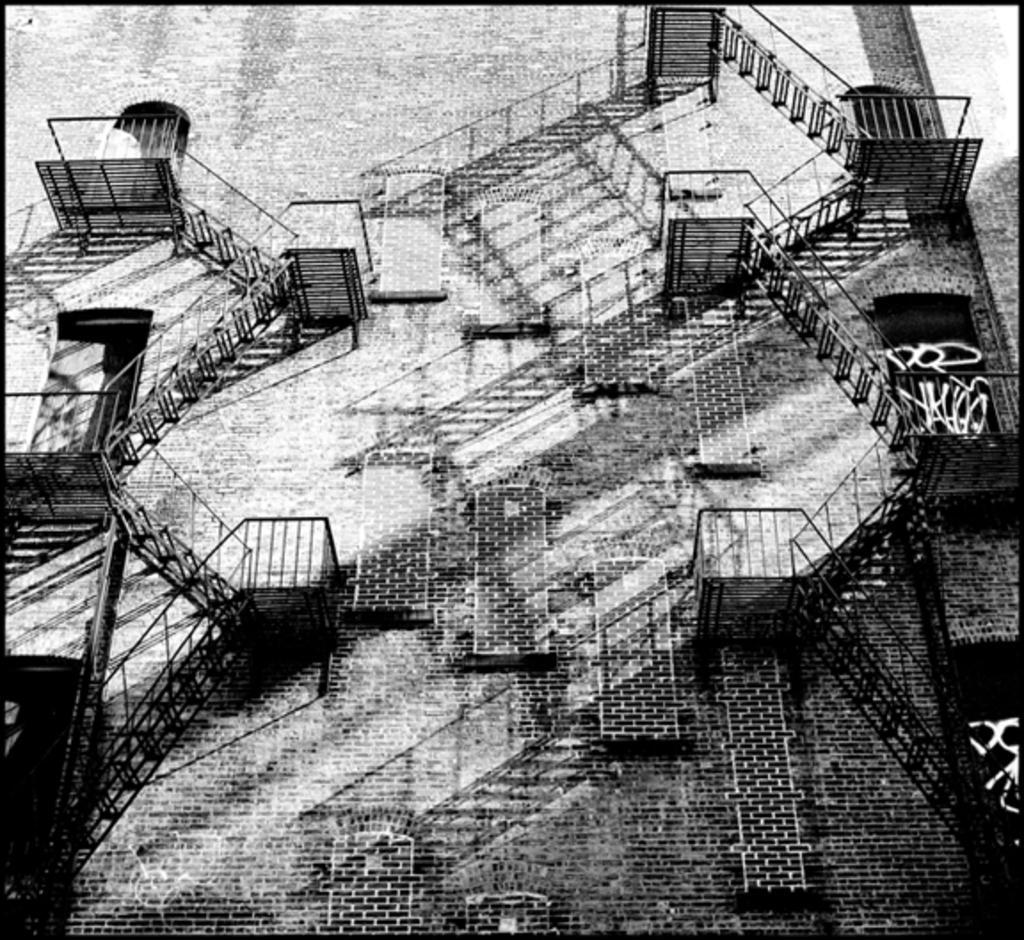How would you summarize this image in a sentence or two? In this image there is a outer view of building where we can see there are stairs in the shape of ladders from one floor to other. 